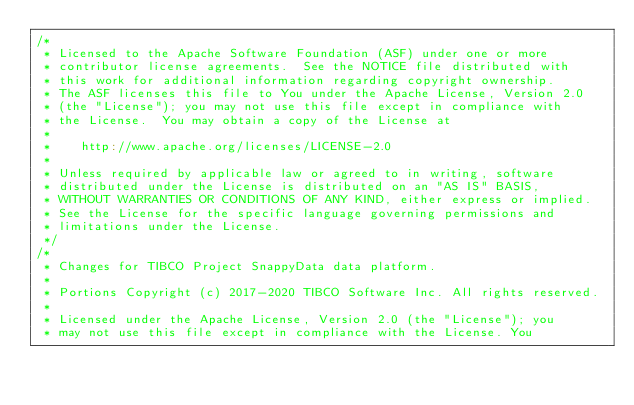<code> <loc_0><loc_0><loc_500><loc_500><_Scala_>/*
 * Licensed to the Apache Software Foundation (ASF) under one or more
 * contributor license agreements.  See the NOTICE file distributed with
 * this work for additional information regarding copyright ownership.
 * The ASF licenses this file to You under the Apache License, Version 2.0
 * (the "License"); you may not use this file except in compliance with
 * the License.  You may obtain a copy of the License at
 *
 *    http://www.apache.org/licenses/LICENSE-2.0
 *
 * Unless required by applicable law or agreed to in writing, software
 * distributed under the License is distributed on an "AS IS" BASIS,
 * WITHOUT WARRANTIES OR CONDITIONS OF ANY KIND, either express or implied.
 * See the License for the specific language governing permissions and
 * limitations under the License.
 */
/*
 * Changes for TIBCO Project SnappyData data platform.
 *
 * Portions Copyright (c) 2017-2020 TIBCO Software Inc. All rights reserved.
 *
 * Licensed under the Apache License, Version 2.0 (the "License"); you
 * may not use this file except in compliance with the License. You</code> 